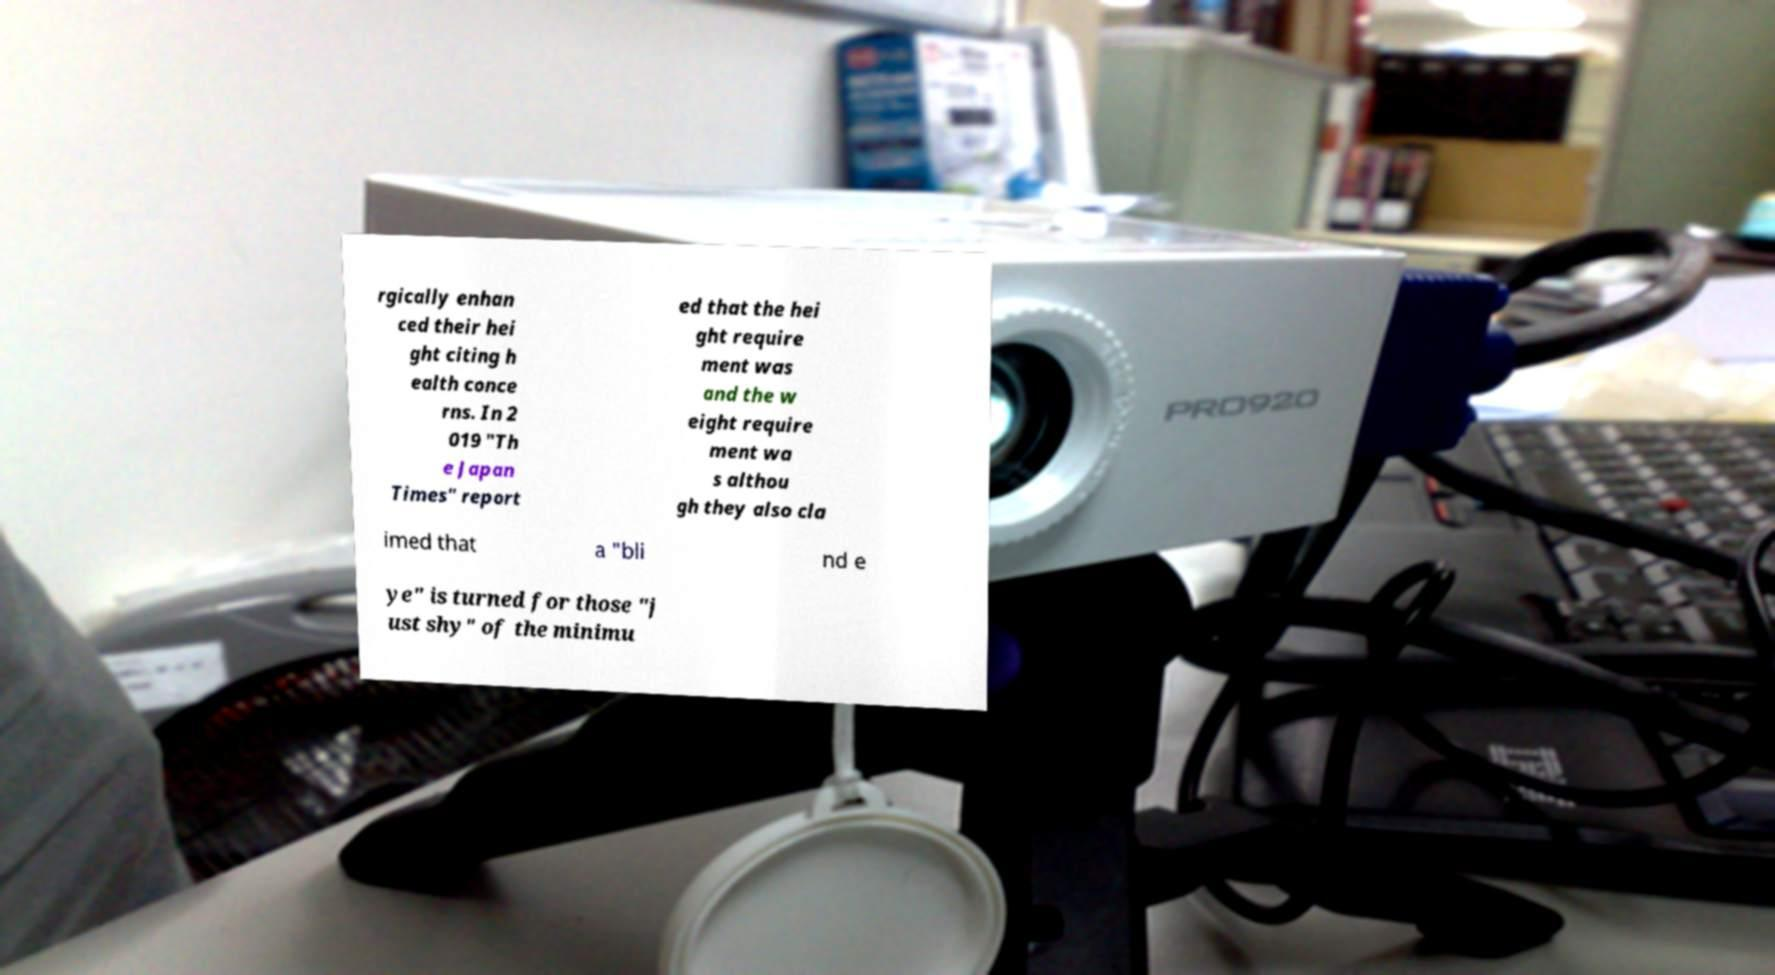I need the written content from this picture converted into text. Can you do that? rgically enhan ced their hei ght citing h ealth conce rns. In 2 019 "Th e Japan Times" report ed that the hei ght require ment was and the w eight require ment wa s althou gh they also cla imed that a "bli nd e ye" is turned for those "j ust shy" of the minimu 